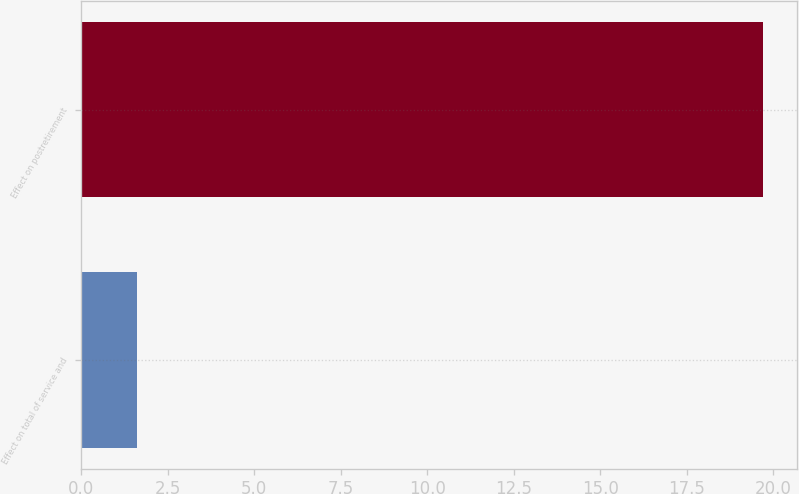<chart> <loc_0><loc_0><loc_500><loc_500><bar_chart><fcel>Effect on total of service and<fcel>Effect on postretirement<nl><fcel>1.6<fcel>19.7<nl></chart> 